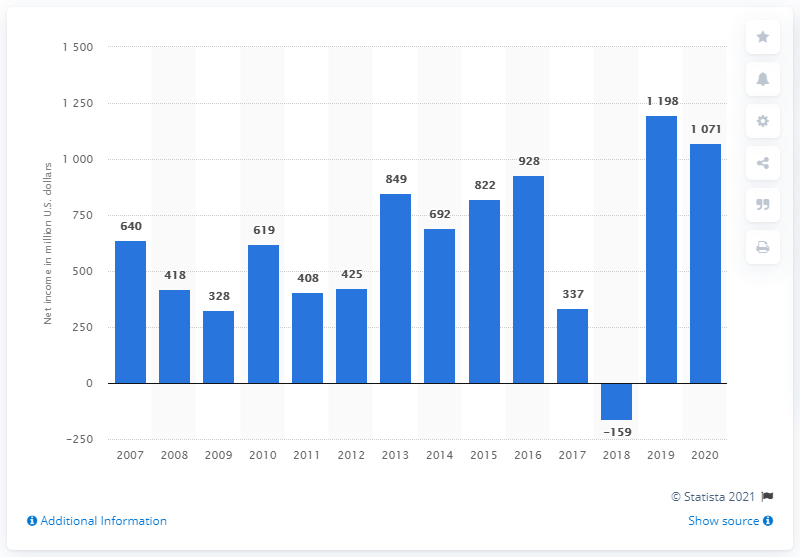Give some essential details in this illustration. In 2018, Whirlpool Corporation experienced a net loss. 